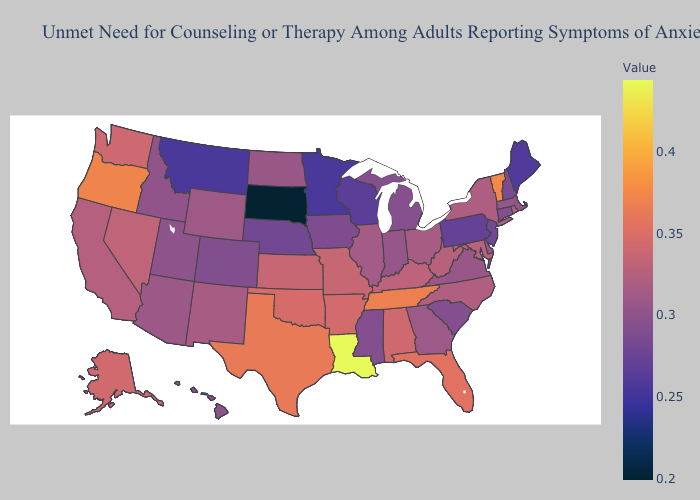Does Montana have the highest value in the USA?
Be succinct. No. Which states have the lowest value in the USA?
Quick response, please. South Dakota. Does the map have missing data?
Give a very brief answer. No. Does Indiana have the lowest value in the USA?
Short answer required. No. Which states have the lowest value in the USA?
Quick response, please. South Dakota. 